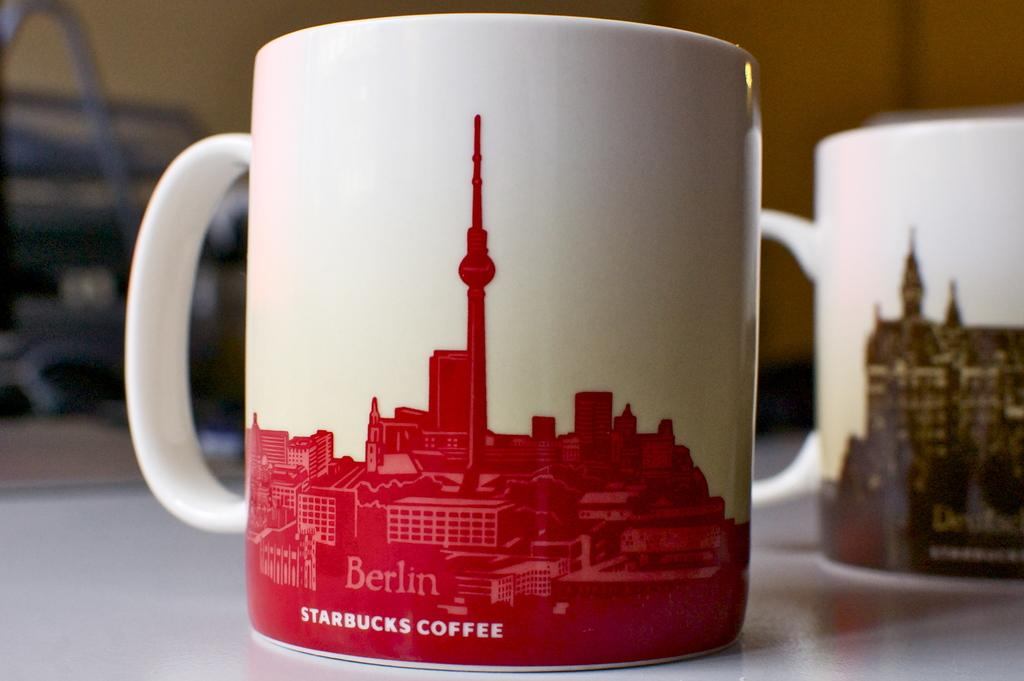<image>
Offer a succinct explanation of the picture presented. a coffee cup with the word Starbucks on it 